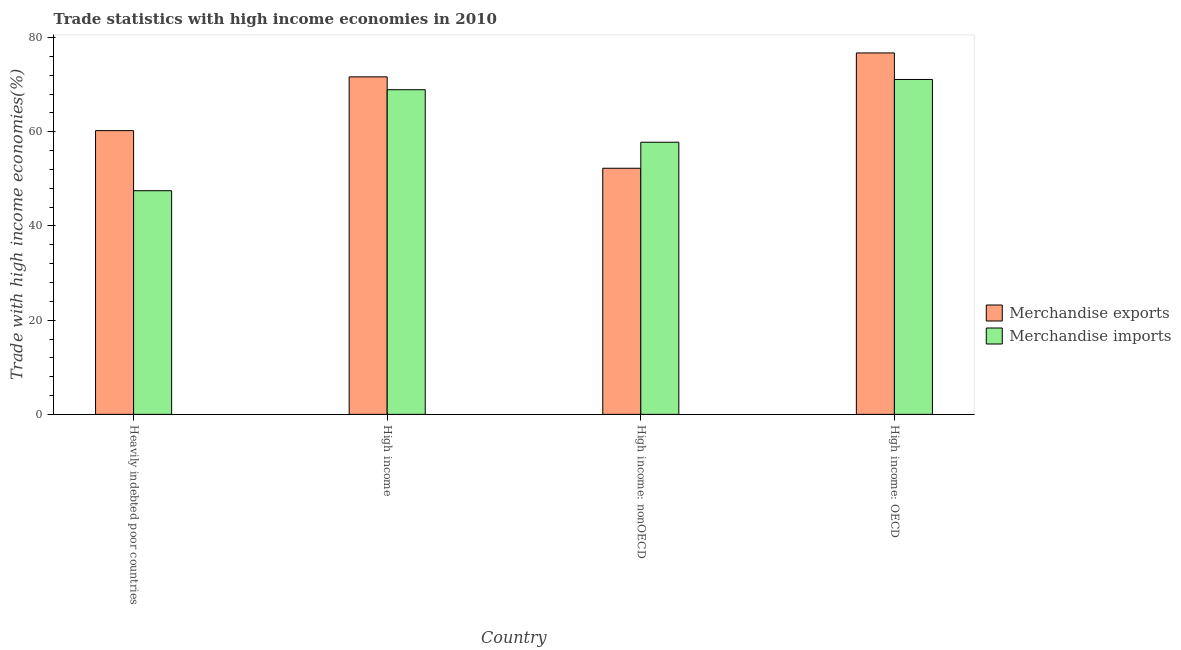Are the number of bars on each tick of the X-axis equal?
Offer a terse response. Yes. How many bars are there on the 1st tick from the left?
Offer a very short reply. 2. What is the label of the 4th group of bars from the left?
Your response must be concise. High income: OECD. What is the merchandise exports in High income?
Provide a succinct answer. 71.66. Across all countries, what is the maximum merchandise imports?
Your response must be concise. 71.11. Across all countries, what is the minimum merchandise exports?
Ensure brevity in your answer.  52.26. In which country was the merchandise exports maximum?
Your answer should be compact. High income: OECD. In which country was the merchandise exports minimum?
Give a very brief answer. High income: nonOECD. What is the total merchandise imports in the graph?
Make the answer very short. 245.32. What is the difference between the merchandise imports in High income and that in High income: nonOECD?
Your answer should be very brief. 11.15. What is the difference between the merchandise exports in High income: nonOECD and the merchandise imports in Heavily indebted poor countries?
Give a very brief answer. 4.77. What is the average merchandise exports per country?
Give a very brief answer. 65.23. What is the difference between the merchandise exports and merchandise imports in High income: OECD?
Your response must be concise. 5.63. In how many countries, is the merchandise exports greater than 40 %?
Give a very brief answer. 4. What is the ratio of the merchandise exports in Heavily indebted poor countries to that in High income: OECD?
Your response must be concise. 0.79. Is the merchandise exports in High income less than that in High income: nonOECD?
Ensure brevity in your answer.  No. Is the difference between the merchandise imports in Heavily indebted poor countries and High income greater than the difference between the merchandise exports in Heavily indebted poor countries and High income?
Offer a terse response. No. What is the difference between the highest and the second highest merchandise exports?
Offer a terse response. 5.08. What is the difference between the highest and the lowest merchandise exports?
Your answer should be very brief. 24.48. In how many countries, is the merchandise exports greater than the average merchandise exports taken over all countries?
Provide a short and direct response. 2. What does the 1st bar from the right in High income: OECD represents?
Your answer should be compact. Merchandise imports. Are all the bars in the graph horizontal?
Your response must be concise. No. Are the values on the major ticks of Y-axis written in scientific E-notation?
Offer a terse response. No. Does the graph contain grids?
Give a very brief answer. No. How many legend labels are there?
Offer a terse response. 2. What is the title of the graph?
Keep it short and to the point. Trade statistics with high income economies in 2010. What is the label or title of the Y-axis?
Your answer should be very brief. Trade with high income economies(%). What is the Trade with high income economies(%) in Merchandise exports in Heavily indebted poor countries?
Your answer should be compact. 60.25. What is the Trade with high income economies(%) of Merchandise imports in Heavily indebted poor countries?
Provide a succinct answer. 47.49. What is the Trade with high income economies(%) in Merchandise exports in High income?
Provide a short and direct response. 71.66. What is the Trade with high income economies(%) in Merchandise imports in High income?
Ensure brevity in your answer.  68.94. What is the Trade with high income economies(%) of Merchandise exports in High income: nonOECD?
Keep it short and to the point. 52.26. What is the Trade with high income economies(%) of Merchandise imports in High income: nonOECD?
Your response must be concise. 57.78. What is the Trade with high income economies(%) of Merchandise exports in High income: OECD?
Your answer should be very brief. 76.74. What is the Trade with high income economies(%) of Merchandise imports in High income: OECD?
Ensure brevity in your answer.  71.11. Across all countries, what is the maximum Trade with high income economies(%) of Merchandise exports?
Keep it short and to the point. 76.74. Across all countries, what is the maximum Trade with high income economies(%) in Merchandise imports?
Provide a short and direct response. 71.11. Across all countries, what is the minimum Trade with high income economies(%) in Merchandise exports?
Give a very brief answer. 52.26. Across all countries, what is the minimum Trade with high income economies(%) of Merchandise imports?
Your response must be concise. 47.49. What is the total Trade with high income economies(%) in Merchandise exports in the graph?
Make the answer very short. 260.91. What is the total Trade with high income economies(%) of Merchandise imports in the graph?
Ensure brevity in your answer.  245.32. What is the difference between the Trade with high income economies(%) of Merchandise exports in Heavily indebted poor countries and that in High income?
Make the answer very short. -11.42. What is the difference between the Trade with high income economies(%) in Merchandise imports in Heavily indebted poor countries and that in High income?
Give a very brief answer. -21.45. What is the difference between the Trade with high income economies(%) in Merchandise exports in Heavily indebted poor countries and that in High income: nonOECD?
Offer a very short reply. 7.99. What is the difference between the Trade with high income economies(%) in Merchandise imports in Heavily indebted poor countries and that in High income: nonOECD?
Your answer should be compact. -10.29. What is the difference between the Trade with high income economies(%) of Merchandise exports in Heavily indebted poor countries and that in High income: OECD?
Keep it short and to the point. -16.49. What is the difference between the Trade with high income economies(%) in Merchandise imports in Heavily indebted poor countries and that in High income: OECD?
Offer a very short reply. -23.62. What is the difference between the Trade with high income economies(%) in Merchandise exports in High income and that in High income: nonOECD?
Give a very brief answer. 19.41. What is the difference between the Trade with high income economies(%) in Merchandise imports in High income and that in High income: nonOECD?
Your answer should be very brief. 11.15. What is the difference between the Trade with high income economies(%) in Merchandise exports in High income and that in High income: OECD?
Keep it short and to the point. -5.08. What is the difference between the Trade with high income economies(%) of Merchandise imports in High income and that in High income: OECD?
Your response must be concise. -2.17. What is the difference between the Trade with high income economies(%) in Merchandise exports in High income: nonOECD and that in High income: OECD?
Offer a terse response. -24.48. What is the difference between the Trade with high income economies(%) of Merchandise imports in High income: nonOECD and that in High income: OECD?
Provide a succinct answer. -13.33. What is the difference between the Trade with high income economies(%) of Merchandise exports in Heavily indebted poor countries and the Trade with high income economies(%) of Merchandise imports in High income?
Keep it short and to the point. -8.69. What is the difference between the Trade with high income economies(%) in Merchandise exports in Heavily indebted poor countries and the Trade with high income economies(%) in Merchandise imports in High income: nonOECD?
Offer a terse response. 2.47. What is the difference between the Trade with high income economies(%) in Merchandise exports in Heavily indebted poor countries and the Trade with high income economies(%) in Merchandise imports in High income: OECD?
Your answer should be very brief. -10.86. What is the difference between the Trade with high income economies(%) in Merchandise exports in High income and the Trade with high income economies(%) in Merchandise imports in High income: nonOECD?
Provide a short and direct response. 13.88. What is the difference between the Trade with high income economies(%) in Merchandise exports in High income and the Trade with high income economies(%) in Merchandise imports in High income: OECD?
Your response must be concise. 0.55. What is the difference between the Trade with high income economies(%) in Merchandise exports in High income: nonOECD and the Trade with high income economies(%) in Merchandise imports in High income: OECD?
Offer a very short reply. -18.85. What is the average Trade with high income economies(%) in Merchandise exports per country?
Your answer should be very brief. 65.23. What is the average Trade with high income economies(%) in Merchandise imports per country?
Your answer should be compact. 61.33. What is the difference between the Trade with high income economies(%) in Merchandise exports and Trade with high income economies(%) in Merchandise imports in Heavily indebted poor countries?
Offer a terse response. 12.76. What is the difference between the Trade with high income economies(%) of Merchandise exports and Trade with high income economies(%) of Merchandise imports in High income?
Your answer should be compact. 2.73. What is the difference between the Trade with high income economies(%) of Merchandise exports and Trade with high income economies(%) of Merchandise imports in High income: nonOECD?
Provide a succinct answer. -5.53. What is the difference between the Trade with high income economies(%) of Merchandise exports and Trade with high income economies(%) of Merchandise imports in High income: OECD?
Offer a very short reply. 5.63. What is the ratio of the Trade with high income economies(%) in Merchandise exports in Heavily indebted poor countries to that in High income?
Offer a very short reply. 0.84. What is the ratio of the Trade with high income economies(%) in Merchandise imports in Heavily indebted poor countries to that in High income?
Keep it short and to the point. 0.69. What is the ratio of the Trade with high income economies(%) in Merchandise exports in Heavily indebted poor countries to that in High income: nonOECD?
Your answer should be compact. 1.15. What is the ratio of the Trade with high income economies(%) in Merchandise imports in Heavily indebted poor countries to that in High income: nonOECD?
Make the answer very short. 0.82. What is the ratio of the Trade with high income economies(%) in Merchandise exports in Heavily indebted poor countries to that in High income: OECD?
Your response must be concise. 0.79. What is the ratio of the Trade with high income economies(%) in Merchandise imports in Heavily indebted poor countries to that in High income: OECD?
Your answer should be compact. 0.67. What is the ratio of the Trade with high income economies(%) of Merchandise exports in High income to that in High income: nonOECD?
Provide a succinct answer. 1.37. What is the ratio of the Trade with high income economies(%) of Merchandise imports in High income to that in High income: nonOECD?
Offer a terse response. 1.19. What is the ratio of the Trade with high income economies(%) of Merchandise exports in High income to that in High income: OECD?
Ensure brevity in your answer.  0.93. What is the ratio of the Trade with high income economies(%) of Merchandise imports in High income to that in High income: OECD?
Give a very brief answer. 0.97. What is the ratio of the Trade with high income economies(%) in Merchandise exports in High income: nonOECD to that in High income: OECD?
Provide a succinct answer. 0.68. What is the ratio of the Trade with high income economies(%) of Merchandise imports in High income: nonOECD to that in High income: OECD?
Provide a succinct answer. 0.81. What is the difference between the highest and the second highest Trade with high income economies(%) in Merchandise exports?
Provide a succinct answer. 5.08. What is the difference between the highest and the second highest Trade with high income economies(%) in Merchandise imports?
Offer a terse response. 2.17. What is the difference between the highest and the lowest Trade with high income economies(%) in Merchandise exports?
Make the answer very short. 24.48. What is the difference between the highest and the lowest Trade with high income economies(%) of Merchandise imports?
Ensure brevity in your answer.  23.62. 